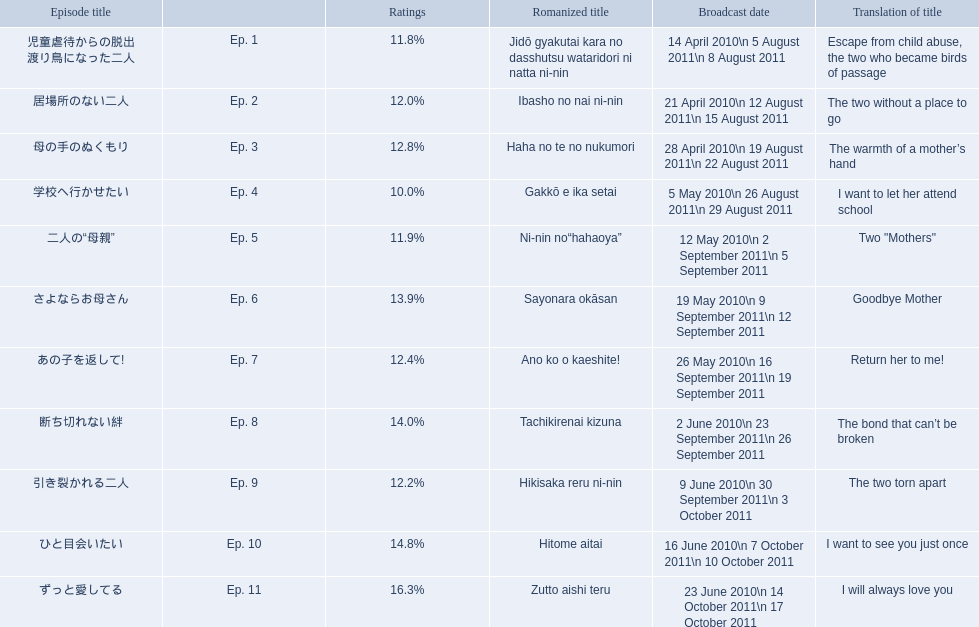What are all the episodes? Ep. 1, Ep. 2, Ep. 3, Ep. 4, Ep. 5, Ep. 6, Ep. 7, Ep. 8, Ep. 9, Ep. 10, Ep. 11. Of these, which ones have a rating of 14%? Ep. 8, Ep. 10. Of these, which one is not ep. 10? Ep. 8. 